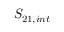Convert formula to latex. <formula><loc_0><loc_0><loc_500><loc_500>S _ { 2 1 , i n t }</formula> 